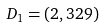Convert formula to latex. <formula><loc_0><loc_0><loc_500><loc_500>D _ { 1 } = ( 2 , 3 2 9 )</formula> 